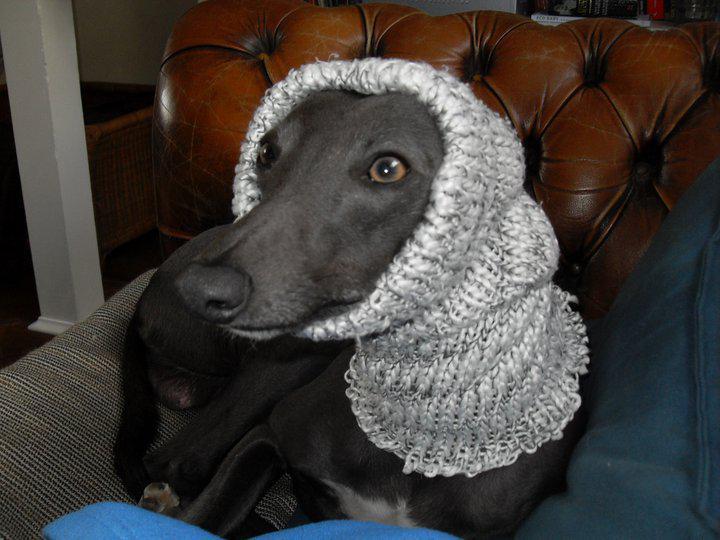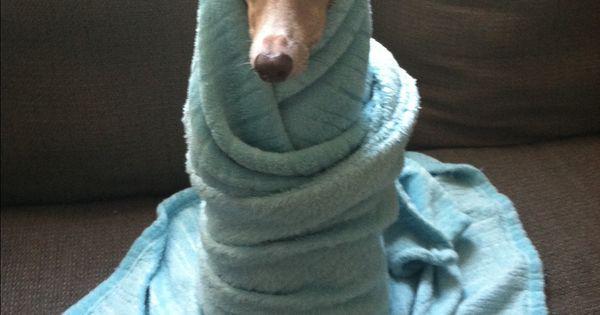The first image is the image on the left, the second image is the image on the right. For the images shown, is this caption "there is an animal wrapped up in something blue in the image on the right side." true? Answer yes or no. Yes. 